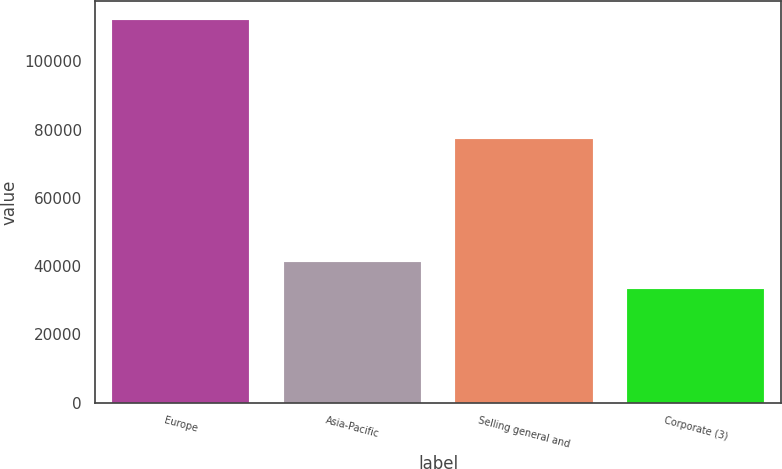Convert chart to OTSL. <chart><loc_0><loc_0><loc_500><loc_500><bar_chart><fcel>Europe<fcel>Asia-Pacific<fcel>Selling general and<fcel>Corporate (3)<nl><fcel>112047<fcel>41220.6<fcel>77162<fcel>33351<nl></chart> 